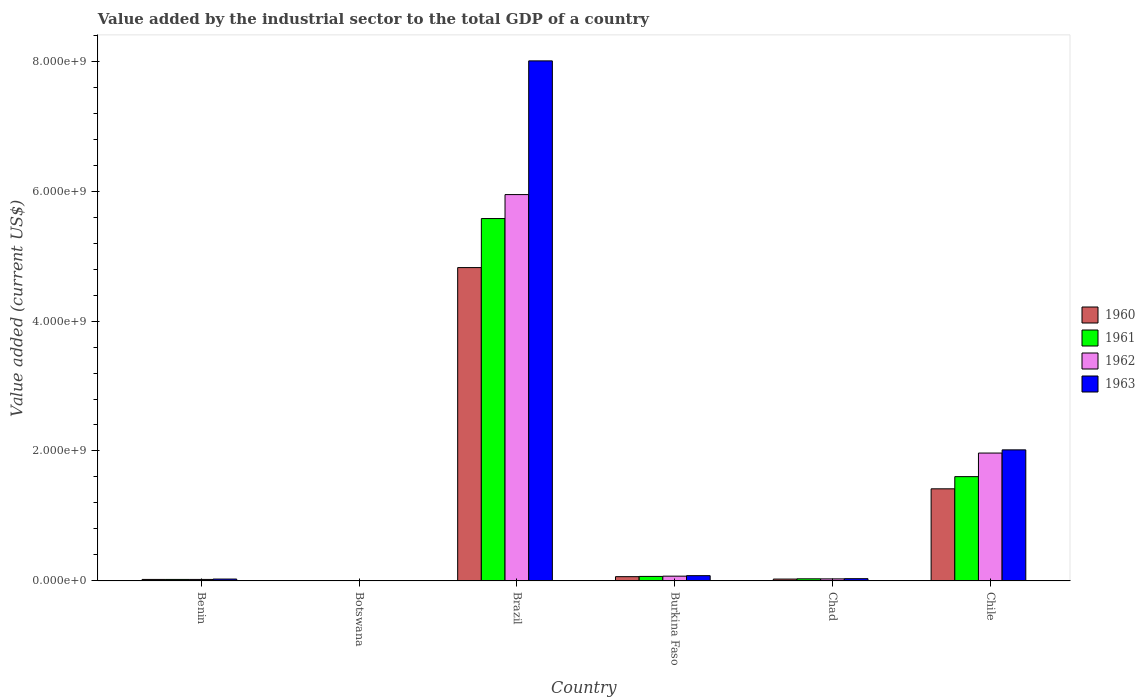How many bars are there on the 5th tick from the left?
Your answer should be very brief. 4. What is the label of the 5th group of bars from the left?
Offer a very short reply. Chad. What is the value added by the industrial sector to the total GDP in 1963 in Brazil?
Offer a very short reply. 8.00e+09. Across all countries, what is the maximum value added by the industrial sector to the total GDP in 1963?
Offer a terse response. 8.00e+09. Across all countries, what is the minimum value added by the industrial sector to the total GDP in 1963?
Make the answer very short. 4.04e+06. In which country was the value added by the industrial sector to the total GDP in 1963 maximum?
Make the answer very short. Brazil. In which country was the value added by the industrial sector to the total GDP in 1961 minimum?
Keep it short and to the point. Botswana. What is the total value added by the industrial sector to the total GDP in 1960 in the graph?
Give a very brief answer. 6.36e+09. What is the difference between the value added by the industrial sector to the total GDP in 1960 in Burkina Faso and that in Chile?
Offer a terse response. -1.35e+09. What is the difference between the value added by the industrial sector to the total GDP in 1960 in Benin and the value added by the industrial sector to the total GDP in 1963 in Botswana?
Ensure brevity in your answer.  1.91e+07. What is the average value added by the industrial sector to the total GDP in 1962 per country?
Ensure brevity in your answer.  1.34e+09. What is the difference between the value added by the industrial sector to the total GDP of/in 1961 and value added by the industrial sector to the total GDP of/in 1962 in Botswana?
Ensure brevity in your answer.  -8106.08. What is the ratio of the value added by the industrial sector to the total GDP in 1963 in Botswana to that in Chile?
Provide a short and direct response. 0. What is the difference between the highest and the second highest value added by the industrial sector to the total GDP in 1962?
Make the answer very short. -1.89e+09. What is the difference between the highest and the lowest value added by the industrial sector to the total GDP in 1961?
Your answer should be very brief. 5.57e+09. Is the sum of the value added by the industrial sector to the total GDP in 1963 in Brazil and Chile greater than the maximum value added by the industrial sector to the total GDP in 1962 across all countries?
Offer a very short reply. Yes. Is it the case that in every country, the sum of the value added by the industrial sector to the total GDP in 1960 and value added by the industrial sector to the total GDP in 1961 is greater than the sum of value added by the industrial sector to the total GDP in 1963 and value added by the industrial sector to the total GDP in 1962?
Ensure brevity in your answer.  No. What does the 3rd bar from the left in Botswana represents?
Your answer should be very brief. 1962. What does the 3rd bar from the right in Chad represents?
Offer a very short reply. 1961. Are all the bars in the graph horizontal?
Your response must be concise. No. How many countries are there in the graph?
Offer a terse response. 6. Does the graph contain any zero values?
Offer a terse response. No. Does the graph contain grids?
Give a very brief answer. No. Where does the legend appear in the graph?
Give a very brief answer. Center right. What is the title of the graph?
Offer a terse response. Value added by the industrial sector to the total GDP of a country. Does "1982" appear as one of the legend labels in the graph?
Make the answer very short. No. What is the label or title of the X-axis?
Your answer should be compact. Country. What is the label or title of the Y-axis?
Offer a very short reply. Value added (current US$). What is the Value added (current US$) in 1960 in Benin?
Keep it short and to the point. 2.31e+07. What is the Value added (current US$) of 1961 in Benin?
Offer a very short reply. 2.31e+07. What is the Value added (current US$) of 1962 in Benin?
Your answer should be compact. 2.32e+07. What is the Value added (current US$) of 1963 in Benin?
Your response must be concise. 2.91e+07. What is the Value added (current US$) of 1960 in Botswana?
Provide a short and direct response. 4.05e+06. What is the Value added (current US$) of 1961 in Botswana?
Provide a succinct answer. 4.05e+06. What is the Value added (current US$) of 1962 in Botswana?
Give a very brief answer. 4.05e+06. What is the Value added (current US$) of 1963 in Botswana?
Your response must be concise. 4.04e+06. What is the Value added (current US$) of 1960 in Brazil?
Ensure brevity in your answer.  4.82e+09. What is the Value added (current US$) in 1961 in Brazil?
Your answer should be compact. 5.58e+09. What is the Value added (current US$) of 1962 in Brazil?
Your answer should be compact. 5.95e+09. What is the Value added (current US$) of 1963 in Brazil?
Make the answer very short. 8.00e+09. What is the Value added (current US$) in 1960 in Burkina Faso?
Provide a succinct answer. 6.58e+07. What is the Value added (current US$) in 1961 in Burkina Faso?
Your answer should be compact. 6.97e+07. What is the Value added (current US$) in 1962 in Burkina Faso?
Keep it short and to the point. 7.35e+07. What is the Value added (current US$) of 1963 in Burkina Faso?
Your answer should be compact. 8.13e+07. What is the Value added (current US$) in 1960 in Chad?
Provide a short and direct response. 2.88e+07. What is the Value added (current US$) of 1961 in Chad?
Keep it short and to the point. 3.27e+07. What is the Value added (current US$) in 1962 in Chad?
Ensure brevity in your answer.  3.17e+07. What is the Value added (current US$) of 1963 in Chad?
Ensure brevity in your answer.  3.49e+07. What is the Value added (current US$) of 1960 in Chile?
Provide a succinct answer. 1.42e+09. What is the Value added (current US$) of 1961 in Chile?
Give a very brief answer. 1.61e+09. What is the Value added (current US$) of 1962 in Chile?
Offer a very short reply. 1.97e+09. What is the Value added (current US$) in 1963 in Chile?
Offer a very short reply. 2.02e+09. Across all countries, what is the maximum Value added (current US$) in 1960?
Your answer should be compact. 4.82e+09. Across all countries, what is the maximum Value added (current US$) in 1961?
Your answer should be compact. 5.58e+09. Across all countries, what is the maximum Value added (current US$) in 1962?
Your answer should be compact. 5.95e+09. Across all countries, what is the maximum Value added (current US$) of 1963?
Keep it short and to the point. 8.00e+09. Across all countries, what is the minimum Value added (current US$) of 1960?
Make the answer very short. 4.05e+06. Across all countries, what is the minimum Value added (current US$) in 1961?
Your response must be concise. 4.05e+06. Across all countries, what is the minimum Value added (current US$) in 1962?
Provide a succinct answer. 4.05e+06. Across all countries, what is the minimum Value added (current US$) in 1963?
Your response must be concise. 4.04e+06. What is the total Value added (current US$) in 1960 in the graph?
Your answer should be very brief. 6.36e+09. What is the total Value added (current US$) in 1961 in the graph?
Give a very brief answer. 7.31e+09. What is the total Value added (current US$) of 1962 in the graph?
Provide a succinct answer. 8.05e+09. What is the total Value added (current US$) of 1963 in the graph?
Make the answer very short. 1.02e+1. What is the difference between the Value added (current US$) in 1960 in Benin and that in Botswana?
Provide a short and direct response. 1.91e+07. What is the difference between the Value added (current US$) of 1961 in Benin and that in Botswana?
Offer a terse response. 1.91e+07. What is the difference between the Value added (current US$) in 1962 in Benin and that in Botswana?
Provide a succinct answer. 1.91e+07. What is the difference between the Value added (current US$) in 1963 in Benin and that in Botswana?
Your response must be concise. 2.51e+07. What is the difference between the Value added (current US$) in 1960 in Benin and that in Brazil?
Your response must be concise. -4.80e+09. What is the difference between the Value added (current US$) in 1961 in Benin and that in Brazil?
Your response must be concise. -5.55e+09. What is the difference between the Value added (current US$) in 1962 in Benin and that in Brazil?
Provide a succinct answer. -5.92e+09. What is the difference between the Value added (current US$) in 1963 in Benin and that in Brazil?
Provide a succinct answer. -7.97e+09. What is the difference between the Value added (current US$) of 1960 in Benin and that in Burkina Faso?
Ensure brevity in your answer.  -4.27e+07. What is the difference between the Value added (current US$) in 1961 in Benin and that in Burkina Faso?
Keep it short and to the point. -4.66e+07. What is the difference between the Value added (current US$) in 1962 in Benin and that in Burkina Faso?
Give a very brief answer. -5.04e+07. What is the difference between the Value added (current US$) of 1963 in Benin and that in Burkina Faso?
Your response must be concise. -5.21e+07. What is the difference between the Value added (current US$) of 1960 in Benin and that in Chad?
Your answer should be very brief. -5.70e+06. What is the difference between the Value added (current US$) of 1961 in Benin and that in Chad?
Your answer should be very brief. -9.53e+06. What is the difference between the Value added (current US$) in 1962 in Benin and that in Chad?
Your answer should be compact. -8.58e+06. What is the difference between the Value added (current US$) in 1963 in Benin and that in Chad?
Your answer should be very brief. -5.75e+06. What is the difference between the Value added (current US$) in 1960 in Benin and that in Chile?
Keep it short and to the point. -1.39e+09. What is the difference between the Value added (current US$) of 1961 in Benin and that in Chile?
Make the answer very short. -1.58e+09. What is the difference between the Value added (current US$) of 1962 in Benin and that in Chile?
Your answer should be compact. -1.94e+09. What is the difference between the Value added (current US$) of 1963 in Benin and that in Chile?
Your answer should be very brief. -1.99e+09. What is the difference between the Value added (current US$) in 1960 in Botswana and that in Brazil?
Offer a very short reply. -4.82e+09. What is the difference between the Value added (current US$) in 1961 in Botswana and that in Brazil?
Make the answer very short. -5.57e+09. What is the difference between the Value added (current US$) of 1962 in Botswana and that in Brazil?
Offer a very short reply. -5.94e+09. What is the difference between the Value added (current US$) of 1963 in Botswana and that in Brazil?
Your answer should be very brief. -8.00e+09. What is the difference between the Value added (current US$) of 1960 in Botswana and that in Burkina Faso?
Ensure brevity in your answer.  -6.17e+07. What is the difference between the Value added (current US$) of 1961 in Botswana and that in Burkina Faso?
Ensure brevity in your answer.  -6.56e+07. What is the difference between the Value added (current US$) of 1962 in Botswana and that in Burkina Faso?
Your answer should be compact. -6.95e+07. What is the difference between the Value added (current US$) of 1963 in Botswana and that in Burkina Faso?
Your response must be concise. -7.72e+07. What is the difference between the Value added (current US$) in 1960 in Botswana and that in Chad?
Make the answer very short. -2.48e+07. What is the difference between the Value added (current US$) in 1961 in Botswana and that in Chad?
Provide a succinct answer. -2.86e+07. What is the difference between the Value added (current US$) in 1962 in Botswana and that in Chad?
Give a very brief answer. -2.77e+07. What is the difference between the Value added (current US$) in 1963 in Botswana and that in Chad?
Provide a succinct answer. -3.08e+07. What is the difference between the Value added (current US$) of 1960 in Botswana and that in Chile?
Provide a short and direct response. -1.41e+09. What is the difference between the Value added (current US$) in 1961 in Botswana and that in Chile?
Keep it short and to the point. -1.60e+09. What is the difference between the Value added (current US$) in 1962 in Botswana and that in Chile?
Provide a short and direct response. -1.96e+09. What is the difference between the Value added (current US$) in 1963 in Botswana and that in Chile?
Provide a succinct answer. -2.01e+09. What is the difference between the Value added (current US$) of 1960 in Brazil and that in Burkina Faso?
Provide a short and direct response. 4.76e+09. What is the difference between the Value added (current US$) in 1961 in Brazil and that in Burkina Faso?
Ensure brevity in your answer.  5.51e+09. What is the difference between the Value added (current US$) in 1962 in Brazil and that in Burkina Faso?
Your answer should be very brief. 5.87e+09. What is the difference between the Value added (current US$) in 1963 in Brazil and that in Burkina Faso?
Your answer should be very brief. 7.92e+09. What is the difference between the Value added (current US$) in 1960 in Brazil and that in Chad?
Make the answer very short. 4.79e+09. What is the difference between the Value added (current US$) of 1961 in Brazil and that in Chad?
Provide a succinct answer. 5.54e+09. What is the difference between the Value added (current US$) in 1962 in Brazil and that in Chad?
Provide a short and direct response. 5.91e+09. What is the difference between the Value added (current US$) of 1963 in Brazil and that in Chad?
Offer a very short reply. 7.97e+09. What is the difference between the Value added (current US$) of 1960 in Brazil and that in Chile?
Your response must be concise. 3.40e+09. What is the difference between the Value added (current US$) in 1961 in Brazil and that in Chile?
Make the answer very short. 3.97e+09. What is the difference between the Value added (current US$) of 1962 in Brazil and that in Chile?
Your answer should be compact. 3.98e+09. What is the difference between the Value added (current US$) of 1963 in Brazil and that in Chile?
Your answer should be compact. 5.99e+09. What is the difference between the Value added (current US$) of 1960 in Burkina Faso and that in Chad?
Your response must be concise. 3.70e+07. What is the difference between the Value added (current US$) in 1961 in Burkina Faso and that in Chad?
Ensure brevity in your answer.  3.70e+07. What is the difference between the Value added (current US$) in 1962 in Burkina Faso and that in Chad?
Keep it short and to the point. 4.18e+07. What is the difference between the Value added (current US$) in 1963 in Burkina Faso and that in Chad?
Provide a short and direct response. 4.64e+07. What is the difference between the Value added (current US$) in 1960 in Burkina Faso and that in Chile?
Offer a terse response. -1.35e+09. What is the difference between the Value added (current US$) of 1961 in Burkina Faso and that in Chile?
Provide a short and direct response. -1.54e+09. What is the difference between the Value added (current US$) of 1962 in Burkina Faso and that in Chile?
Offer a terse response. -1.89e+09. What is the difference between the Value added (current US$) in 1963 in Burkina Faso and that in Chile?
Your answer should be very brief. -1.94e+09. What is the difference between the Value added (current US$) in 1960 in Chad and that in Chile?
Make the answer very short. -1.39e+09. What is the difference between the Value added (current US$) of 1961 in Chad and that in Chile?
Ensure brevity in your answer.  -1.57e+09. What is the difference between the Value added (current US$) of 1962 in Chad and that in Chile?
Keep it short and to the point. -1.94e+09. What is the difference between the Value added (current US$) of 1963 in Chad and that in Chile?
Your answer should be compact. -1.98e+09. What is the difference between the Value added (current US$) of 1960 in Benin and the Value added (current US$) of 1961 in Botswana?
Offer a very short reply. 1.91e+07. What is the difference between the Value added (current US$) in 1960 in Benin and the Value added (current US$) in 1962 in Botswana?
Keep it short and to the point. 1.91e+07. What is the difference between the Value added (current US$) in 1960 in Benin and the Value added (current US$) in 1963 in Botswana?
Your answer should be very brief. 1.91e+07. What is the difference between the Value added (current US$) of 1961 in Benin and the Value added (current US$) of 1962 in Botswana?
Offer a very short reply. 1.91e+07. What is the difference between the Value added (current US$) in 1961 in Benin and the Value added (current US$) in 1963 in Botswana?
Your response must be concise. 1.91e+07. What is the difference between the Value added (current US$) in 1962 in Benin and the Value added (current US$) in 1963 in Botswana?
Provide a short and direct response. 1.91e+07. What is the difference between the Value added (current US$) of 1960 in Benin and the Value added (current US$) of 1961 in Brazil?
Provide a succinct answer. -5.55e+09. What is the difference between the Value added (current US$) of 1960 in Benin and the Value added (current US$) of 1962 in Brazil?
Offer a terse response. -5.92e+09. What is the difference between the Value added (current US$) of 1960 in Benin and the Value added (current US$) of 1963 in Brazil?
Keep it short and to the point. -7.98e+09. What is the difference between the Value added (current US$) of 1961 in Benin and the Value added (current US$) of 1962 in Brazil?
Offer a very short reply. -5.92e+09. What is the difference between the Value added (current US$) in 1961 in Benin and the Value added (current US$) in 1963 in Brazil?
Your answer should be compact. -7.98e+09. What is the difference between the Value added (current US$) of 1962 in Benin and the Value added (current US$) of 1963 in Brazil?
Give a very brief answer. -7.98e+09. What is the difference between the Value added (current US$) in 1960 in Benin and the Value added (current US$) in 1961 in Burkina Faso?
Offer a very short reply. -4.65e+07. What is the difference between the Value added (current US$) in 1960 in Benin and the Value added (current US$) in 1962 in Burkina Faso?
Your answer should be very brief. -5.04e+07. What is the difference between the Value added (current US$) of 1960 in Benin and the Value added (current US$) of 1963 in Burkina Faso?
Give a very brief answer. -5.81e+07. What is the difference between the Value added (current US$) of 1961 in Benin and the Value added (current US$) of 1962 in Burkina Faso?
Your response must be concise. -5.04e+07. What is the difference between the Value added (current US$) in 1961 in Benin and the Value added (current US$) in 1963 in Burkina Faso?
Ensure brevity in your answer.  -5.81e+07. What is the difference between the Value added (current US$) in 1962 in Benin and the Value added (current US$) in 1963 in Burkina Faso?
Ensure brevity in your answer.  -5.81e+07. What is the difference between the Value added (current US$) of 1960 in Benin and the Value added (current US$) of 1961 in Chad?
Your answer should be very brief. -9.52e+06. What is the difference between the Value added (current US$) of 1960 in Benin and the Value added (current US$) of 1962 in Chad?
Your answer should be compact. -8.60e+06. What is the difference between the Value added (current US$) of 1960 in Benin and the Value added (current US$) of 1963 in Chad?
Give a very brief answer. -1.17e+07. What is the difference between the Value added (current US$) of 1961 in Benin and the Value added (current US$) of 1962 in Chad?
Your answer should be compact. -8.61e+06. What is the difference between the Value added (current US$) of 1961 in Benin and the Value added (current US$) of 1963 in Chad?
Your answer should be compact. -1.17e+07. What is the difference between the Value added (current US$) of 1962 in Benin and the Value added (current US$) of 1963 in Chad?
Provide a succinct answer. -1.17e+07. What is the difference between the Value added (current US$) of 1960 in Benin and the Value added (current US$) of 1961 in Chile?
Make the answer very short. -1.58e+09. What is the difference between the Value added (current US$) of 1960 in Benin and the Value added (current US$) of 1962 in Chile?
Make the answer very short. -1.94e+09. What is the difference between the Value added (current US$) of 1960 in Benin and the Value added (current US$) of 1963 in Chile?
Ensure brevity in your answer.  -1.99e+09. What is the difference between the Value added (current US$) in 1961 in Benin and the Value added (current US$) in 1962 in Chile?
Offer a terse response. -1.94e+09. What is the difference between the Value added (current US$) in 1961 in Benin and the Value added (current US$) in 1963 in Chile?
Provide a succinct answer. -1.99e+09. What is the difference between the Value added (current US$) of 1962 in Benin and the Value added (current US$) of 1963 in Chile?
Offer a very short reply. -1.99e+09. What is the difference between the Value added (current US$) of 1960 in Botswana and the Value added (current US$) of 1961 in Brazil?
Your answer should be very brief. -5.57e+09. What is the difference between the Value added (current US$) of 1960 in Botswana and the Value added (current US$) of 1962 in Brazil?
Keep it short and to the point. -5.94e+09. What is the difference between the Value added (current US$) of 1960 in Botswana and the Value added (current US$) of 1963 in Brazil?
Make the answer very short. -8.00e+09. What is the difference between the Value added (current US$) in 1961 in Botswana and the Value added (current US$) in 1962 in Brazil?
Your response must be concise. -5.94e+09. What is the difference between the Value added (current US$) of 1961 in Botswana and the Value added (current US$) of 1963 in Brazil?
Your answer should be compact. -8.00e+09. What is the difference between the Value added (current US$) in 1962 in Botswana and the Value added (current US$) in 1963 in Brazil?
Offer a very short reply. -8.00e+09. What is the difference between the Value added (current US$) in 1960 in Botswana and the Value added (current US$) in 1961 in Burkina Faso?
Make the answer very short. -6.56e+07. What is the difference between the Value added (current US$) of 1960 in Botswana and the Value added (current US$) of 1962 in Burkina Faso?
Provide a succinct answer. -6.95e+07. What is the difference between the Value added (current US$) of 1960 in Botswana and the Value added (current US$) of 1963 in Burkina Faso?
Your answer should be compact. -7.72e+07. What is the difference between the Value added (current US$) of 1961 in Botswana and the Value added (current US$) of 1962 in Burkina Faso?
Keep it short and to the point. -6.95e+07. What is the difference between the Value added (current US$) in 1961 in Botswana and the Value added (current US$) in 1963 in Burkina Faso?
Your response must be concise. -7.72e+07. What is the difference between the Value added (current US$) in 1962 in Botswana and the Value added (current US$) in 1963 in Burkina Faso?
Provide a short and direct response. -7.72e+07. What is the difference between the Value added (current US$) in 1960 in Botswana and the Value added (current US$) in 1961 in Chad?
Keep it short and to the point. -2.86e+07. What is the difference between the Value added (current US$) in 1960 in Botswana and the Value added (current US$) in 1962 in Chad?
Your answer should be compact. -2.77e+07. What is the difference between the Value added (current US$) in 1960 in Botswana and the Value added (current US$) in 1963 in Chad?
Your answer should be very brief. -3.08e+07. What is the difference between the Value added (current US$) of 1961 in Botswana and the Value added (current US$) of 1962 in Chad?
Offer a very short reply. -2.77e+07. What is the difference between the Value added (current US$) in 1961 in Botswana and the Value added (current US$) in 1963 in Chad?
Ensure brevity in your answer.  -3.08e+07. What is the difference between the Value added (current US$) of 1962 in Botswana and the Value added (current US$) of 1963 in Chad?
Give a very brief answer. -3.08e+07. What is the difference between the Value added (current US$) of 1960 in Botswana and the Value added (current US$) of 1961 in Chile?
Make the answer very short. -1.60e+09. What is the difference between the Value added (current US$) in 1960 in Botswana and the Value added (current US$) in 1962 in Chile?
Offer a terse response. -1.96e+09. What is the difference between the Value added (current US$) of 1960 in Botswana and the Value added (current US$) of 1963 in Chile?
Ensure brevity in your answer.  -2.01e+09. What is the difference between the Value added (current US$) in 1961 in Botswana and the Value added (current US$) in 1962 in Chile?
Offer a terse response. -1.96e+09. What is the difference between the Value added (current US$) of 1961 in Botswana and the Value added (current US$) of 1963 in Chile?
Your answer should be compact. -2.01e+09. What is the difference between the Value added (current US$) in 1962 in Botswana and the Value added (current US$) in 1963 in Chile?
Your answer should be compact. -2.01e+09. What is the difference between the Value added (current US$) of 1960 in Brazil and the Value added (current US$) of 1961 in Burkina Faso?
Make the answer very short. 4.75e+09. What is the difference between the Value added (current US$) in 1960 in Brazil and the Value added (current US$) in 1962 in Burkina Faso?
Ensure brevity in your answer.  4.75e+09. What is the difference between the Value added (current US$) of 1960 in Brazil and the Value added (current US$) of 1963 in Burkina Faso?
Your response must be concise. 4.74e+09. What is the difference between the Value added (current US$) of 1961 in Brazil and the Value added (current US$) of 1962 in Burkina Faso?
Give a very brief answer. 5.50e+09. What is the difference between the Value added (current US$) in 1961 in Brazil and the Value added (current US$) in 1963 in Burkina Faso?
Keep it short and to the point. 5.50e+09. What is the difference between the Value added (current US$) in 1962 in Brazil and the Value added (current US$) in 1963 in Burkina Faso?
Provide a succinct answer. 5.86e+09. What is the difference between the Value added (current US$) of 1960 in Brazil and the Value added (current US$) of 1961 in Chad?
Make the answer very short. 4.79e+09. What is the difference between the Value added (current US$) of 1960 in Brazil and the Value added (current US$) of 1962 in Chad?
Ensure brevity in your answer.  4.79e+09. What is the difference between the Value added (current US$) of 1960 in Brazil and the Value added (current US$) of 1963 in Chad?
Make the answer very short. 4.79e+09. What is the difference between the Value added (current US$) in 1961 in Brazil and the Value added (current US$) in 1962 in Chad?
Offer a terse response. 5.55e+09. What is the difference between the Value added (current US$) in 1961 in Brazil and the Value added (current US$) in 1963 in Chad?
Provide a succinct answer. 5.54e+09. What is the difference between the Value added (current US$) in 1962 in Brazil and the Value added (current US$) in 1963 in Chad?
Offer a terse response. 5.91e+09. What is the difference between the Value added (current US$) in 1960 in Brazil and the Value added (current US$) in 1961 in Chile?
Your answer should be compact. 3.22e+09. What is the difference between the Value added (current US$) of 1960 in Brazil and the Value added (current US$) of 1962 in Chile?
Offer a very short reply. 2.85e+09. What is the difference between the Value added (current US$) of 1960 in Brazil and the Value added (current US$) of 1963 in Chile?
Keep it short and to the point. 2.81e+09. What is the difference between the Value added (current US$) of 1961 in Brazil and the Value added (current US$) of 1962 in Chile?
Offer a very short reply. 3.61e+09. What is the difference between the Value added (current US$) in 1961 in Brazil and the Value added (current US$) in 1963 in Chile?
Ensure brevity in your answer.  3.56e+09. What is the difference between the Value added (current US$) of 1962 in Brazil and the Value added (current US$) of 1963 in Chile?
Provide a succinct answer. 3.93e+09. What is the difference between the Value added (current US$) in 1960 in Burkina Faso and the Value added (current US$) in 1961 in Chad?
Offer a very short reply. 3.32e+07. What is the difference between the Value added (current US$) of 1960 in Burkina Faso and the Value added (current US$) of 1962 in Chad?
Provide a succinct answer. 3.41e+07. What is the difference between the Value added (current US$) in 1960 in Burkina Faso and the Value added (current US$) in 1963 in Chad?
Provide a succinct answer. 3.09e+07. What is the difference between the Value added (current US$) of 1961 in Burkina Faso and the Value added (current US$) of 1962 in Chad?
Ensure brevity in your answer.  3.79e+07. What is the difference between the Value added (current US$) of 1961 in Burkina Faso and the Value added (current US$) of 1963 in Chad?
Ensure brevity in your answer.  3.48e+07. What is the difference between the Value added (current US$) in 1962 in Burkina Faso and the Value added (current US$) in 1963 in Chad?
Your response must be concise. 3.86e+07. What is the difference between the Value added (current US$) in 1960 in Burkina Faso and the Value added (current US$) in 1961 in Chile?
Provide a succinct answer. -1.54e+09. What is the difference between the Value added (current US$) of 1960 in Burkina Faso and the Value added (current US$) of 1962 in Chile?
Give a very brief answer. -1.90e+09. What is the difference between the Value added (current US$) of 1960 in Burkina Faso and the Value added (current US$) of 1963 in Chile?
Give a very brief answer. -1.95e+09. What is the difference between the Value added (current US$) of 1961 in Burkina Faso and the Value added (current US$) of 1962 in Chile?
Ensure brevity in your answer.  -1.90e+09. What is the difference between the Value added (current US$) in 1961 in Burkina Faso and the Value added (current US$) in 1963 in Chile?
Offer a very short reply. -1.95e+09. What is the difference between the Value added (current US$) of 1962 in Burkina Faso and the Value added (current US$) of 1963 in Chile?
Your answer should be compact. -1.94e+09. What is the difference between the Value added (current US$) of 1960 in Chad and the Value added (current US$) of 1961 in Chile?
Your answer should be very brief. -1.58e+09. What is the difference between the Value added (current US$) in 1960 in Chad and the Value added (current US$) in 1962 in Chile?
Your response must be concise. -1.94e+09. What is the difference between the Value added (current US$) of 1960 in Chad and the Value added (current US$) of 1963 in Chile?
Your response must be concise. -1.99e+09. What is the difference between the Value added (current US$) in 1961 in Chad and the Value added (current US$) in 1962 in Chile?
Your answer should be very brief. -1.94e+09. What is the difference between the Value added (current US$) of 1961 in Chad and the Value added (current US$) of 1963 in Chile?
Your answer should be very brief. -1.98e+09. What is the difference between the Value added (current US$) of 1962 in Chad and the Value added (current US$) of 1963 in Chile?
Keep it short and to the point. -1.99e+09. What is the average Value added (current US$) in 1960 per country?
Offer a very short reply. 1.06e+09. What is the average Value added (current US$) in 1961 per country?
Ensure brevity in your answer.  1.22e+09. What is the average Value added (current US$) of 1962 per country?
Give a very brief answer. 1.34e+09. What is the average Value added (current US$) in 1963 per country?
Keep it short and to the point. 1.70e+09. What is the difference between the Value added (current US$) of 1960 and Value added (current US$) of 1961 in Benin?
Offer a terse response. 6130.83. What is the difference between the Value added (current US$) in 1960 and Value added (current US$) in 1962 in Benin?
Your answer should be compact. -1.71e+04. What is the difference between the Value added (current US$) of 1960 and Value added (current US$) of 1963 in Benin?
Your answer should be very brief. -5.99e+06. What is the difference between the Value added (current US$) in 1961 and Value added (current US$) in 1962 in Benin?
Your answer should be compact. -2.32e+04. What is the difference between the Value added (current US$) of 1961 and Value added (current US$) of 1963 in Benin?
Your answer should be compact. -6.00e+06. What is the difference between the Value added (current US$) in 1962 and Value added (current US$) in 1963 in Benin?
Keep it short and to the point. -5.97e+06. What is the difference between the Value added (current US$) of 1960 and Value added (current US$) of 1961 in Botswana?
Ensure brevity in your answer.  7791.27. What is the difference between the Value added (current US$) in 1960 and Value added (current US$) in 1962 in Botswana?
Offer a very short reply. -314.81. What is the difference between the Value added (current US$) in 1960 and Value added (current US$) in 1963 in Botswana?
Offer a terse response. 1.11e+04. What is the difference between the Value added (current US$) of 1961 and Value added (current US$) of 1962 in Botswana?
Offer a very short reply. -8106.08. What is the difference between the Value added (current US$) of 1961 and Value added (current US$) of 1963 in Botswana?
Keep it short and to the point. 3353.04. What is the difference between the Value added (current US$) of 1962 and Value added (current US$) of 1963 in Botswana?
Give a very brief answer. 1.15e+04. What is the difference between the Value added (current US$) in 1960 and Value added (current US$) in 1961 in Brazil?
Your response must be concise. -7.55e+08. What is the difference between the Value added (current US$) of 1960 and Value added (current US$) of 1962 in Brazil?
Offer a very short reply. -1.12e+09. What is the difference between the Value added (current US$) in 1960 and Value added (current US$) in 1963 in Brazil?
Provide a short and direct response. -3.18e+09. What is the difference between the Value added (current US$) in 1961 and Value added (current US$) in 1962 in Brazil?
Give a very brief answer. -3.69e+08. What is the difference between the Value added (current US$) of 1961 and Value added (current US$) of 1963 in Brazil?
Make the answer very short. -2.43e+09. What is the difference between the Value added (current US$) in 1962 and Value added (current US$) in 1963 in Brazil?
Provide a succinct answer. -2.06e+09. What is the difference between the Value added (current US$) in 1960 and Value added (current US$) in 1961 in Burkina Faso?
Ensure brevity in your answer.  -3.88e+06. What is the difference between the Value added (current US$) in 1960 and Value added (current US$) in 1962 in Burkina Faso?
Provide a succinct answer. -7.71e+06. What is the difference between the Value added (current US$) of 1960 and Value added (current US$) of 1963 in Burkina Faso?
Your answer should be very brief. -1.55e+07. What is the difference between the Value added (current US$) of 1961 and Value added (current US$) of 1962 in Burkina Faso?
Provide a short and direct response. -3.83e+06. What is the difference between the Value added (current US$) in 1961 and Value added (current US$) in 1963 in Burkina Faso?
Your answer should be very brief. -1.16e+07. What is the difference between the Value added (current US$) in 1962 and Value added (current US$) in 1963 in Burkina Faso?
Provide a short and direct response. -7.75e+06. What is the difference between the Value added (current US$) of 1960 and Value added (current US$) of 1961 in Chad?
Offer a very short reply. -3.82e+06. What is the difference between the Value added (current US$) of 1960 and Value added (current US$) of 1962 in Chad?
Provide a succinct answer. -2.90e+06. What is the difference between the Value added (current US$) of 1960 and Value added (current US$) of 1963 in Chad?
Make the answer very short. -6.04e+06. What is the difference between the Value added (current US$) in 1961 and Value added (current US$) in 1962 in Chad?
Ensure brevity in your answer.  9.19e+05. What is the difference between the Value added (current US$) in 1961 and Value added (current US$) in 1963 in Chad?
Your answer should be compact. -2.22e+06. What is the difference between the Value added (current US$) in 1962 and Value added (current US$) in 1963 in Chad?
Your answer should be compact. -3.14e+06. What is the difference between the Value added (current US$) of 1960 and Value added (current US$) of 1961 in Chile?
Offer a very short reply. -1.88e+08. What is the difference between the Value added (current US$) in 1960 and Value added (current US$) in 1962 in Chile?
Offer a very short reply. -5.50e+08. What is the difference between the Value added (current US$) in 1960 and Value added (current US$) in 1963 in Chile?
Your answer should be compact. -5.99e+08. What is the difference between the Value added (current US$) of 1961 and Value added (current US$) of 1962 in Chile?
Make the answer very short. -3.63e+08. What is the difference between the Value added (current US$) in 1961 and Value added (current US$) in 1963 in Chile?
Provide a succinct answer. -4.12e+08. What is the difference between the Value added (current US$) in 1962 and Value added (current US$) in 1963 in Chile?
Your response must be concise. -4.92e+07. What is the ratio of the Value added (current US$) in 1960 in Benin to that in Botswana?
Keep it short and to the point. 5.71. What is the ratio of the Value added (current US$) of 1961 in Benin to that in Botswana?
Offer a very short reply. 5.72. What is the ratio of the Value added (current US$) of 1962 in Benin to that in Botswana?
Keep it short and to the point. 5.71. What is the ratio of the Value added (current US$) of 1963 in Benin to that in Botswana?
Your answer should be very brief. 7.2. What is the ratio of the Value added (current US$) of 1960 in Benin to that in Brazil?
Provide a succinct answer. 0. What is the ratio of the Value added (current US$) in 1961 in Benin to that in Brazil?
Give a very brief answer. 0. What is the ratio of the Value added (current US$) of 1962 in Benin to that in Brazil?
Provide a succinct answer. 0. What is the ratio of the Value added (current US$) of 1963 in Benin to that in Brazil?
Ensure brevity in your answer.  0. What is the ratio of the Value added (current US$) of 1960 in Benin to that in Burkina Faso?
Ensure brevity in your answer.  0.35. What is the ratio of the Value added (current US$) of 1961 in Benin to that in Burkina Faso?
Keep it short and to the point. 0.33. What is the ratio of the Value added (current US$) of 1962 in Benin to that in Burkina Faso?
Offer a terse response. 0.31. What is the ratio of the Value added (current US$) in 1963 in Benin to that in Burkina Faso?
Offer a very short reply. 0.36. What is the ratio of the Value added (current US$) in 1960 in Benin to that in Chad?
Offer a terse response. 0.8. What is the ratio of the Value added (current US$) of 1961 in Benin to that in Chad?
Ensure brevity in your answer.  0.71. What is the ratio of the Value added (current US$) of 1962 in Benin to that in Chad?
Your response must be concise. 0.73. What is the ratio of the Value added (current US$) in 1963 in Benin to that in Chad?
Your response must be concise. 0.84. What is the ratio of the Value added (current US$) in 1960 in Benin to that in Chile?
Make the answer very short. 0.02. What is the ratio of the Value added (current US$) of 1961 in Benin to that in Chile?
Your answer should be very brief. 0.01. What is the ratio of the Value added (current US$) of 1962 in Benin to that in Chile?
Make the answer very short. 0.01. What is the ratio of the Value added (current US$) in 1963 in Benin to that in Chile?
Your response must be concise. 0.01. What is the ratio of the Value added (current US$) of 1960 in Botswana to that in Brazil?
Your response must be concise. 0. What is the ratio of the Value added (current US$) in 1961 in Botswana to that in Brazil?
Your response must be concise. 0. What is the ratio of the Value added (current US$) of 1962 in Botswana to that in Brazil?
Your response must be concise. 0. What is the ratio of the Value added (current US$) of 1963 in Botswana to that in Brazil?
Provide a succinct answer. 0. What is the ratio of the Value added (current US$) of 1960 in Botswana to that in Burkina Faso?
Give a very brief answer. 0.06. What is the ratio of the Value added (current US$) of 1961 in Botswana to that in Burkina Faso?
Give a very brief answer. 0.06. What is the ratio of the Value added (current US$) of 1962 in Botswana to that in Burkina Faso?
Provide a succinct answer. 0.06. What is the ratio of the Value added (current US$) in 1963 in Botswana to that in Burkina Faso?
Keep it short and to the point. 0.05. What is the ratio of the Value added (current US$) in 1960 in Botswana to that in Chad?
Give a very brief answer. 0.14. What is the ratio of the Value added (current US$) in 1961 in Botswana to that in Chad?
Your response must be concise. 0.12. What is the ratio of the Value added (current US$) of 1962 in Botswana to that in Chad?
Your answer should be very brief. 0.13. What is the ratio of the Value added (current US$) in 1963 in Botswana to that in Chad?
Give a very brief answer. 0.12. What is the ratio of the Value added (current US$) of 1960 in Botswana to that in Chile?
Give a very brief answer. 0. What is the ratio of the Value added (current US$) of 1961 in Botswana to that in Chile?
Your response must be concise. 0. What is the ratio of the Value added (current US$) in 1962 in Botswana to that in Chile?
Your answer should be very brief. 0. What is the ratio of the Value added (current US$) in 1963 in Botswana to that in Chile?
Your answer should be very brief. 0. What is the ratio of the Value added (current US$) of 1960 in Brazil to that in Burkina Faso?
Give a very brief answer. 73.29. What is the ratio of the Value added (current US$) of 1961 in Brazil to that in Burkina Faso?
Your answer should be very brief. 80.04. What is the ratio of the Value added (current US$) of 1962 in Brazil to that in Burkina Faso?
Your response must be concise. 80.89. What is the ratio of the Value added (current US$) of 1963 in Brazil to that in Burkina Faso?
Keep it short and to the point. 98.49. What is the ratio of the Value added (current US$) of 1960 in Brazil to that in Chad?
Ensure brevity in your answer.  167.26. What is the ratio of the Value added (current US$) of 1961 in Brazil to that in Chad?
Offer a very short reply. 170.8. What is the ratio of the Value added (current US$) of 1962 in Brazil to that in Chad?
Provide a succinct answer. 187.38. What is the ratio of the Value added (current US$) of 1963 in Brazil to that in Chad?
Provide a short and direct response. 229.53. What is the ratio of the Value added (current US$) in 1960 in Brazil to that in Chile?
Make the answer very short. 3.4. What is the ratio of the Value added (current US$) in 1961 in Brazil to that in Chile?
Provide a succinct answer. 3.47. What is the ratio of the Value added (current US$) of 1962 in Brazil to that in Chile?
Ensure brevity in your answer.  3.02. What is the ratio of the Value added (current US$) in 1963 in Brazil to that in Chile?
Offer a terse response. 3.97. What is the ratio of the Value added (current US$) of 1960 in Burkina Faso to that in Chad?
Your response must be concise. 2.28. What is the ratio of the Value added (current US$) of 1961 in Burkina Faso to that in Chad?
Make the answer very short. 2.13. What is the ratio of the Value added (current US$) in 1962 in Burkina Faso to that in Chad?
Your answer should be very brief. 2.32. What is the ratio of the Value added (current US$) of 1963 in Burkina Faso to that in Chad?
Give a very brief answer. 2.33. What is the ratio of the Value added (current US$) of 1960 in Burkina Faso to that in Chile?
Provide a succinct answer. 0.05. What is the ratio of the Value added (current US$) of 1961 in Burkina Faso to that in Chile?
Your response must be concise. 0.04. What is the ratio of the Value added (current US$) in 1962 in Burkina Faso to that in Chile?
Provide a succinct answer. 0.04. What is the ratio of the Value added (current US$) of 1963 in Burkina Faso to that in Chile?
Ensure brevity in your answer.  0.04. What is the ratio of the Value added (current US$) in 1960 in Chad to that in Chile?
Offer a very short reply. 0.02. What is the ratio of the Value added (current US$) in 1961 in Chad to that in Chile?
Provide a succinct answer. 0.02. What is the ratio of the Value added (current US$) of 1962 in Chad to that in Chile?
Offer a very short reply. 0.02. What is the ratio of the Value added (current US$) of 1963 in Chad to that in Chile?
Make the answer very short. 0.02. What is the difference between the highest and the second highest Value added (current US$) of 1960?
Ensure brevity in your answer.  3.40e+09. What is the difference between the highest and the second highest Value added (current US$) of 1961?
Provide a short and direct response. 3.97e+09. What is the difference between the highest and the second highest Value added (current US$) of 1962?
Make the answer very short. 3.98e+09. What is the difference between the highest and the second highest Value added (current US$) in 1963?
Keep it short and to the point. 5.99e+09. What is the difference between the highest and the lowest Value added (current US$) in 1960?
Provide a short and direct response. 4.82e+09. What is the difference between the highest and the lowest Value added (current US$) in 1961?
Your answer should be compact. 5.57e+09. What is the difference between the highest and the lowest Value added (current US$) of 1962?
Provide a short and direct response. 5.94e+09. What is the difference between the highest and the lowest Value added (current US$) of 1963?
Your answer should be very brief. 8.00e+09. 